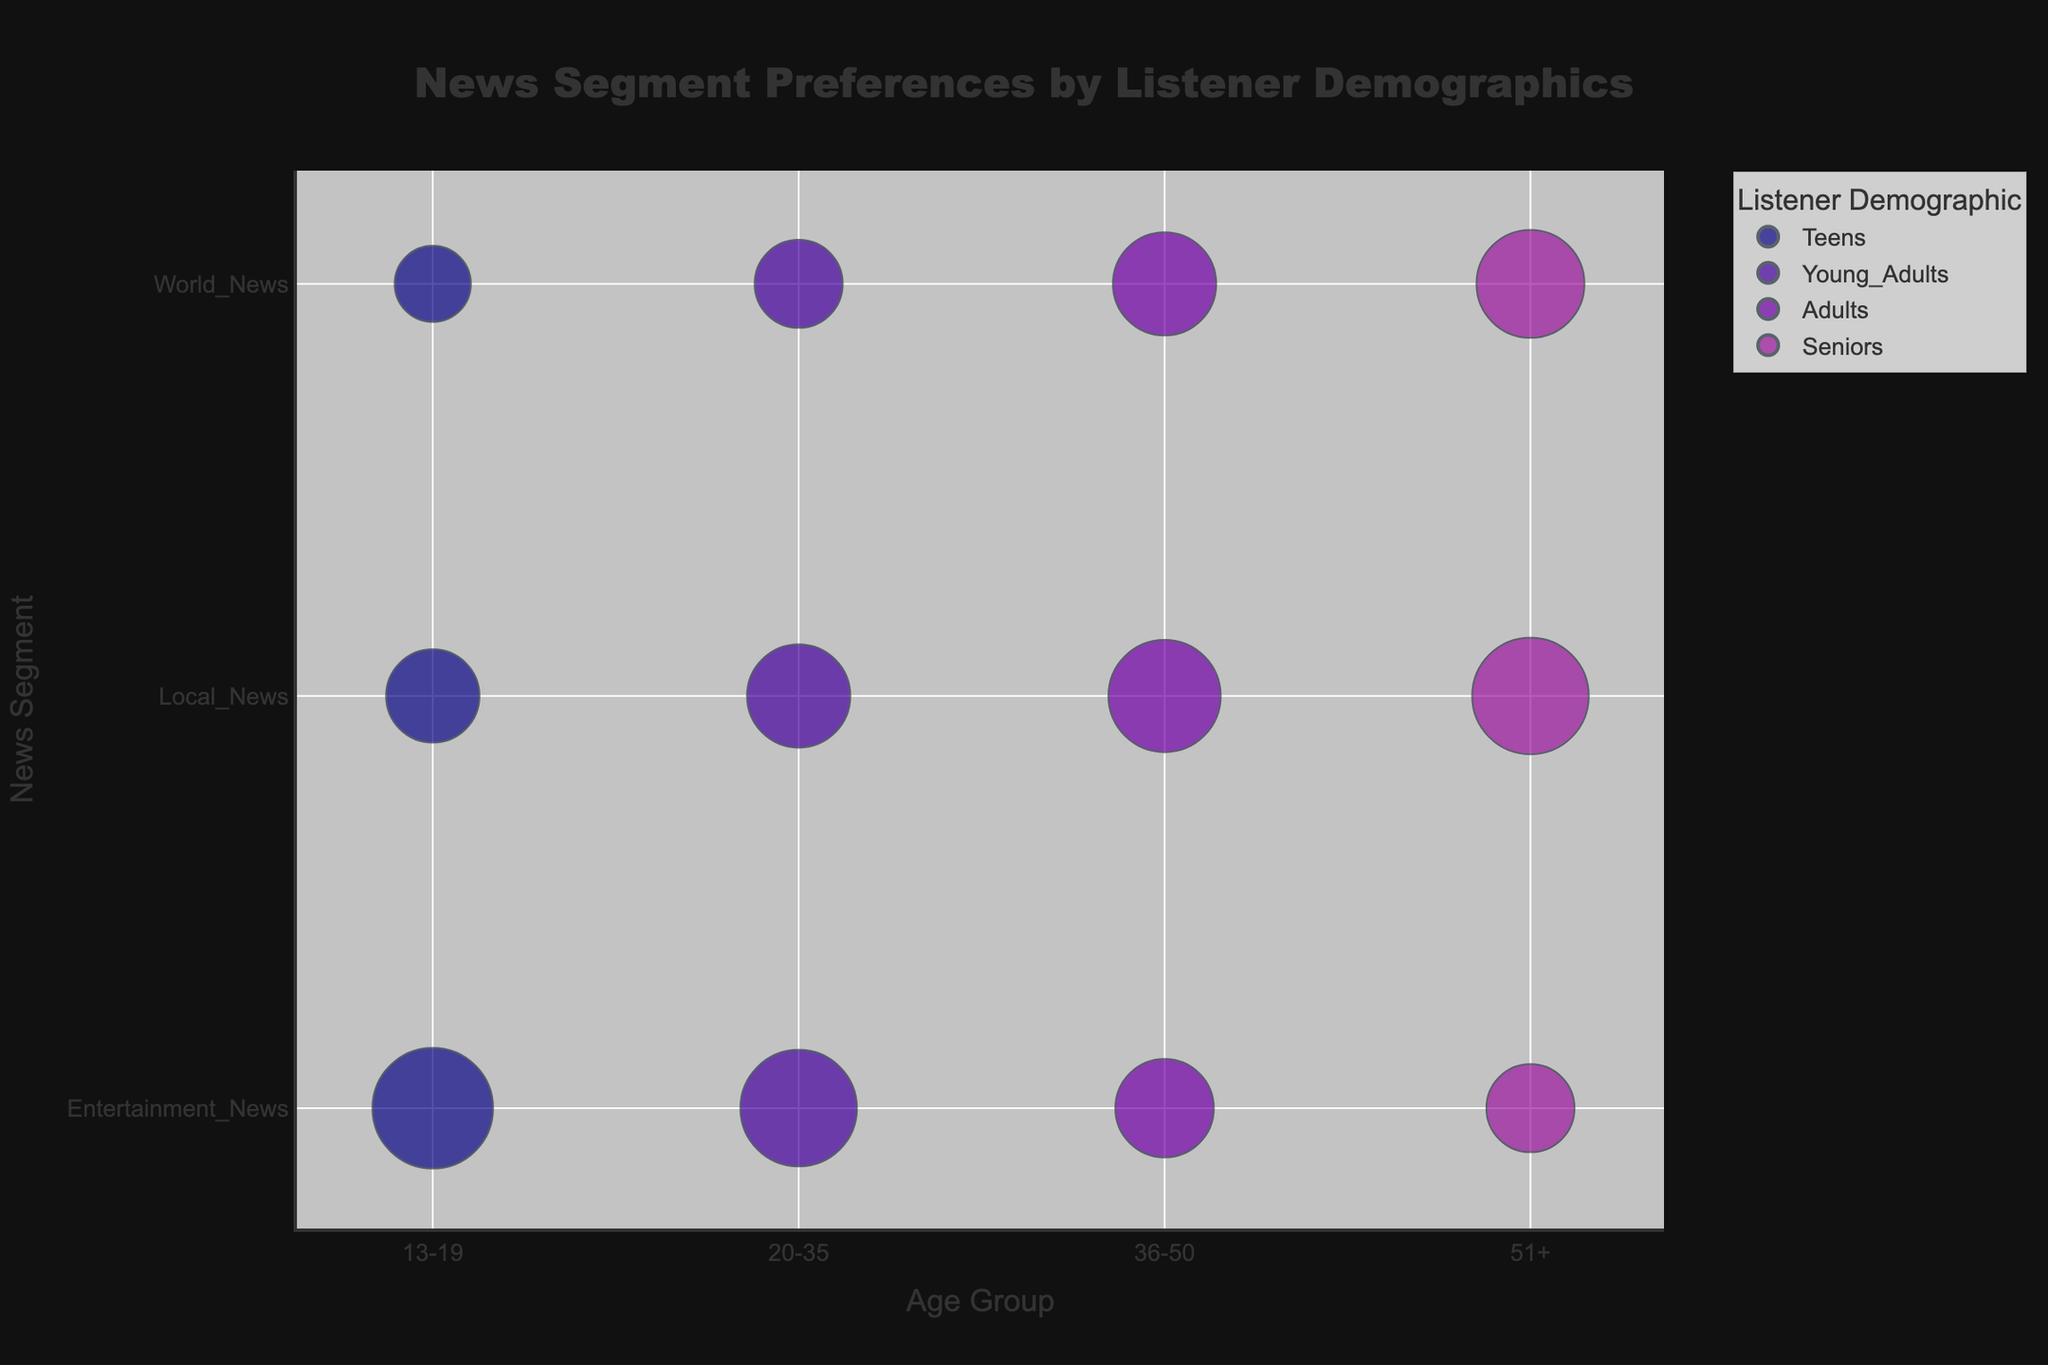What is the title of the figure? The title is usually placed at the top center of the figure. In this case, it reads "News Segment Preferences by Listener Demographics".
Answer: News Segment Preferences by Listener Demographics Which age group prefers "Community Events" in Local News? "Community Events" is listed as a news segment preferred by Teens, which is indicated by the hover information on the bubble plot.
Answer: Teens What news segment has the highest popularity score for the Seniors age group? By looking at the sizes of the bubbles, "Health Advisories" for Local News has the largest bubble among Seniors, indicating the highest popularity score.
Answer: Health Advisories Compare the popularity scores for "Entertainment News" between Teens and Young Adults. Which age group prefers it more? By comparing the size of the bubbles for "Entertainment News" under Teens and Young Adults, the Teen bubble for "Celebrity Gossip" (75) is larger than the Young Adults bubble for "Music Industry Updates" (70).
Answer: Teens What is the average popularity score for Local News across all age groups? The popularity scores for Local News are 45 (Teens), 55 (Young Adults), 65 (Adults), and 70 (Seniors). Summing these scores equals 235, and dividing by the number of groups (4) gives an average of 58.75.
Answer: 58.75 What is the least preferred news segment for Young Adults? By looking at the smallest bubble size under Young Adults, "Global Economy" in World News has the smallest popularity score (40).
Answer: Global Economy Which demographic shows the least interest in World News and which specific news segment reflects this? By examining the size of the bubbles in World News across demographics, Teens show the least interest, reflected by the bubble size for "Political News" (30).
Answer: Teens, Political News How does the preference for "Television News" by Adults compare to "Classical Arts" by Seniors in terms of popularity score? The bubble for "Television News" under Adults has a popularity score of 50, while "Classical Arts" for Seniors has a score of 40. Thus, Adults prefer "Television News" more.
Answer: Adults, 50 vs. 40 What is the sum of the popularity scores for World News across all age groups? The popularity scores for World News are 30 (Teens), 40 (Young Adults), 55 (Adults), and 60 (Seniors). Adding these scores results in a total of 185.
Answer: 185 